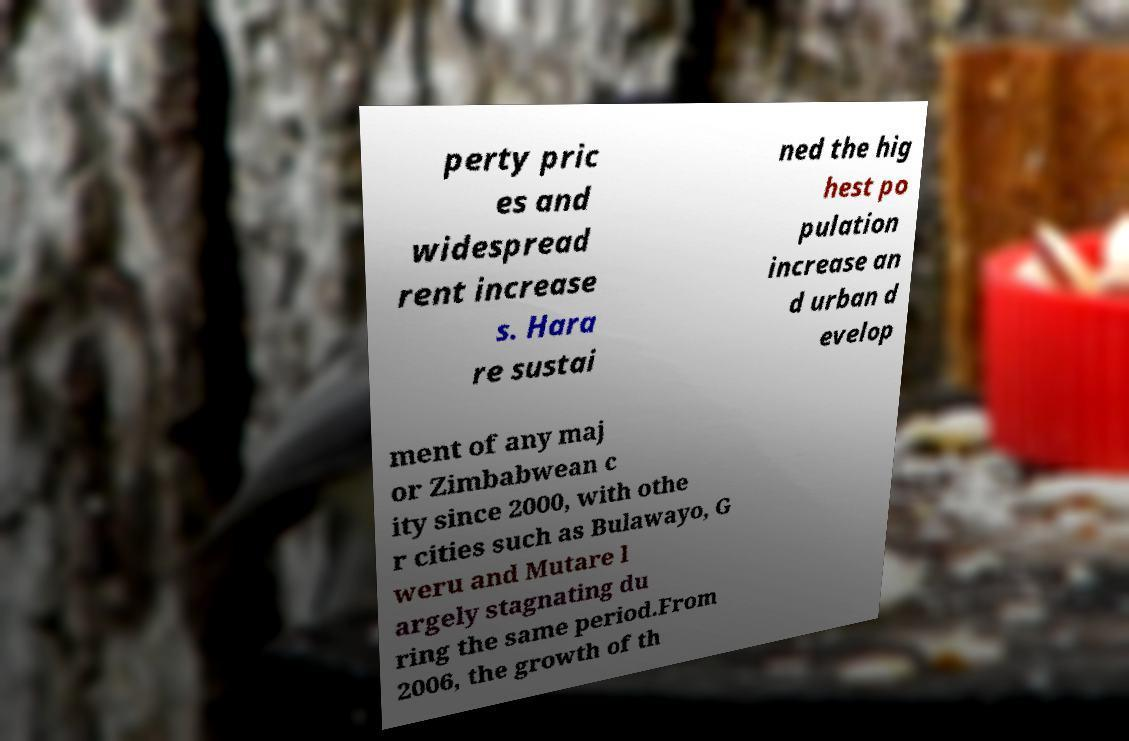Can you read and provide the text displayed in the image?This photo seems to have some interesting text. Can you extract and type it out for me? perty pric es and widespread rent increase s. Hara re sustai ned the hig hest po pulation increase an d urban d evelop ment of any maj or Zimbabwean c ity since 2000, with othe r cities such as Bulawayo, G weru and Mutare l argely stagnating du ring the same period.From 2006, the growth of th 